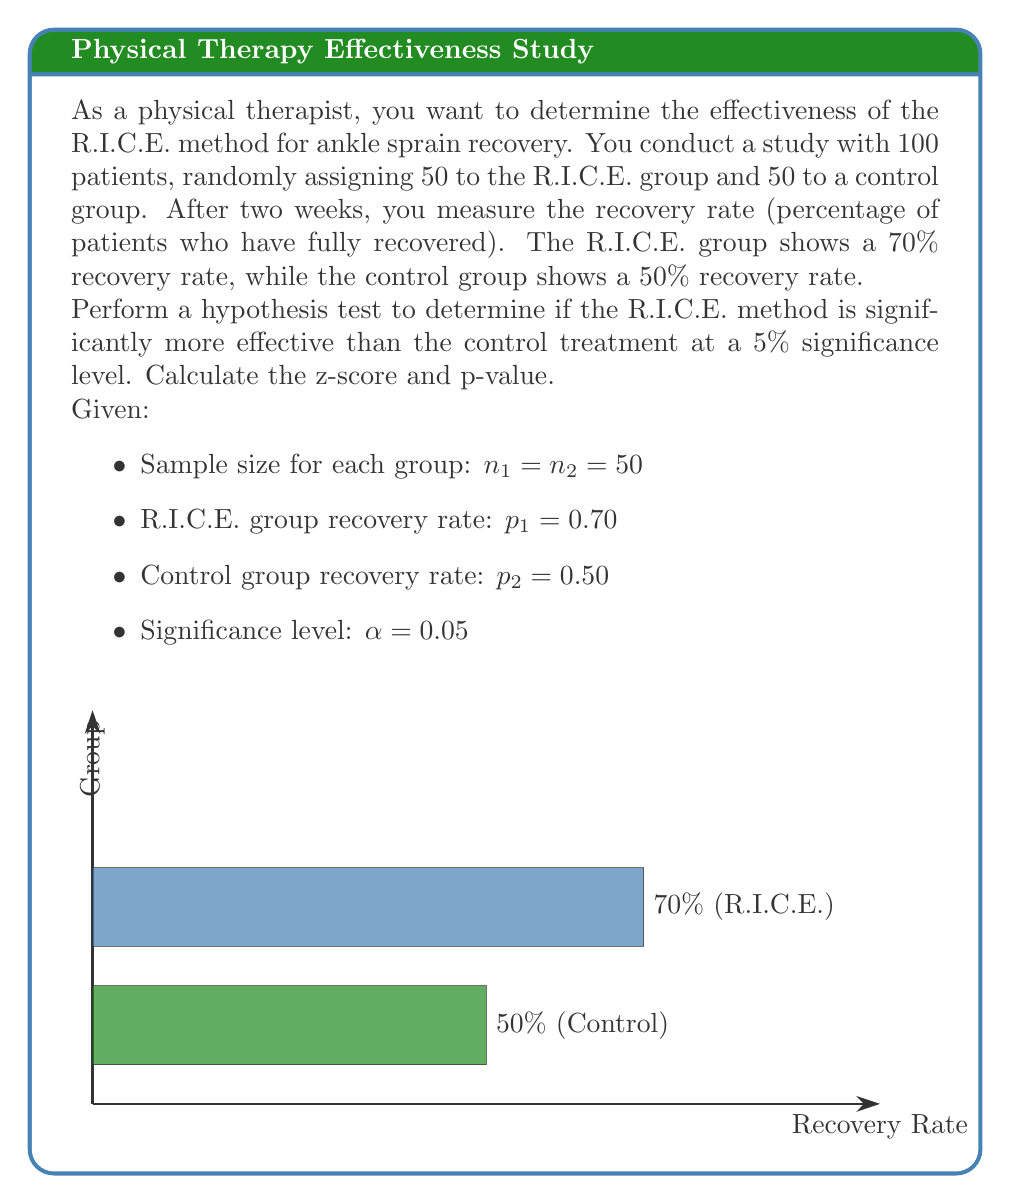Can you solve this math problem? To determine if the R.I.C.E. method is significantly more effective, we'll perform a two-proportion z-test.

Step 1: State the hypotheses
$H_0: p_1 - p_2 = 0$ (null hypothesis)
$H_a: p_1 - p_2 > 0$ (alternative hypothesis, one-tailed test)

Step 2: Calculate the pooled proportion
$$p = \frac{X_1 + X_2}{n_1 + n_2} = \frac{35 + 25}{50 + 50} = \frac{60}{100} = 0.60$$

Step 3: Calculate the standard error
$$SE = \sqrt{p(1-p)(\frac{1}{n_1} + \frac{1}{n_2})} = \sqrt{0.60(0.40)(\frac{1}{50} + \frac{1}{50})} = 0.0980$$

Step 4: Calculate the z-score
$$z = \frac{(p_1 - p_2) - 0}{SE} = \frac{0.70 - 0.50}{0.0980} = 2.0408$$

Step 5: Find the p-value
For a one-tailed test, p-value = P(Z > 2.0408)
Using a standard normal distribution table or calculator:
p-value ≈ 0.0207

Step 6: Compare p-value to significance level
0.0207 < 0.05, so we reject the null hypothesis.

Conclusion: There is sufficient evidence to conclude that the R.I.C.E. method is significantly more effective than the control treatment at the 5% significance level.
Answer: Reject $H_0$, p-value = 0.0207 < 0.05 